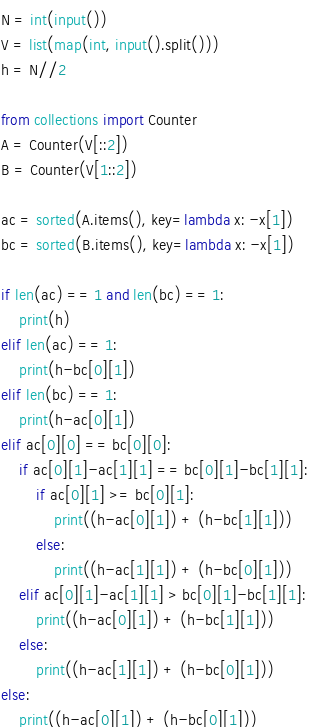Convert code to text. <code><loc_0><loc_0><loc_500><loc_500><_Python_>N = int(input())
V = list(map(int, input().split()))
h = N//2

from collections import Counter
A = Counter(V[::2])
B = Counter(V[1::2])

ac = sorted(A.items(), key=lambda x: -x[1])
bc = sorted(B.items(), key=lambda x: -x[1])

if len(ac) == 1 and len(bc) == 1:
    print(h)
elif len(ac) == 1:
    print(h-bc[0][1])
elif len(bc) == 1:
    print(h-ac[0][1])
elif ac[0][0] == bc[0][0]:
    if ac[0][1]-ac[1][1] == bc[0][1]-bc[1][1]:
        if ac[0][1] >= bc[0][1]:
            print((h-ac[0][1]) + (h-bc[1][1]))
        else:
            print((h-ac[1][1]) + (h-bc[0][1]))
    elif ac[0][1]-ac[1][1] > bc[0][1]-bc[1][1]:
        print((h-ac[0][1]) + (h-bc[1][1]))
    else:
        print((h-ac[1][1]) + (h-bc[0][1]))
else:
    print((h-ac[0][1]) + (h-bc[0][1]))</code> 